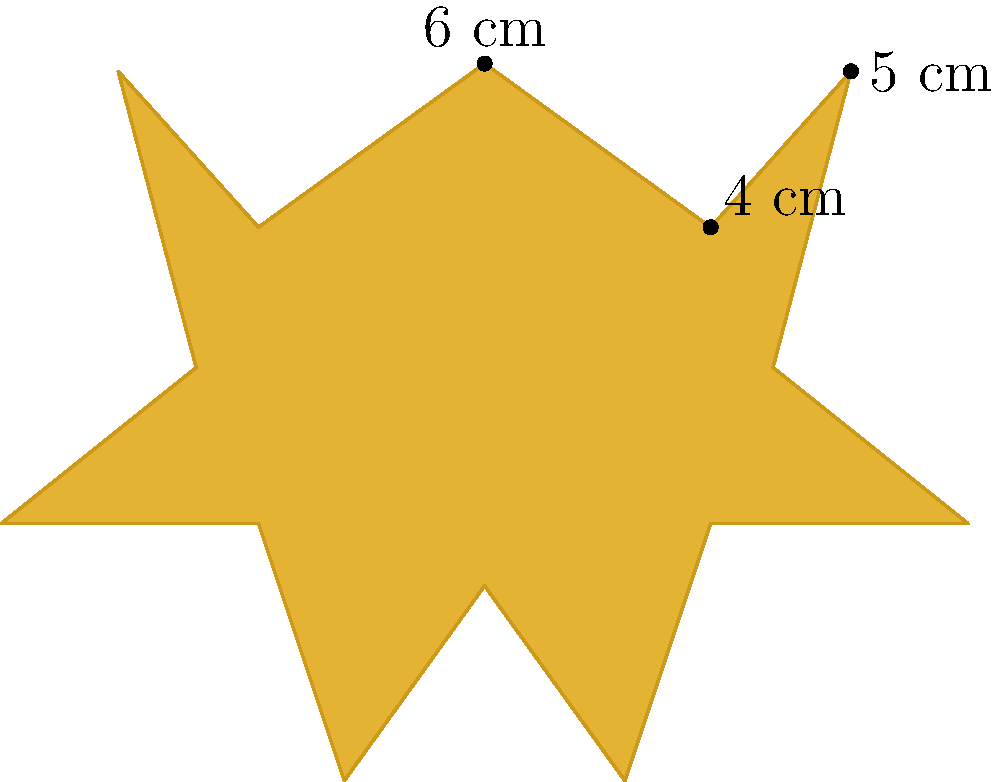As an aspiring filmmaker, you've been nominated for an LGBTQ+ Film Festival award. The star-shaped award plaque has the following measurements: the distance from the center to any outer point is 6 cm, the distance between two adjacent outer points is 4 cm, and the distance from an outer point to the midpoint of the opposite side is 5 cm. Calculate the area of the award plaque. To calculate the area of the star-shaped award plaque, we can break it down into triangles and use the formula for the area of a triangle.

Step 1: Determine the number of triangles in the star.
The star has 10 triangles (5 pointing outward and 5 inward).

Step 2: Calculate the area of one outward-pointing triangle.
Using the given measurements:
Base (b) = 4 cm
Height (h) = 5 cm
Area of one outward triangle = $\frac{1}{2} \times b \times h = \frac{1}{2} \times 4 \times 5 = 10$ cm²

Step 3: Calculate the area of one inward-pointing triangle.
We need to find the height of this triangle:
$h = \sqrt{6^2 - 2^2} = \sqrt{36 - 4} = \sqrt{32} = 4\sqrt{2}$ cm
Area of one inward triangle = $\frac{1}{2} \times 4 \times 4\sqrt{2} = 4\sqrt{2}$ cm²

Step 4: Calculate the total area of the star.
Total area = $(5 \times \text{Area of outward triangle}) + (5 \times \text{Area of inward triangle})$
$= (5 \times 10) + (5 \times 4\sqrt{2})$
$= 50 + 20\sqrt{2}$ cm²

Therefore, the area of the star-shaped award plaque is $50 + 20\sqrt{2}$ cm².
Answer: $50 + 20\sqrt{2}$ cm² 